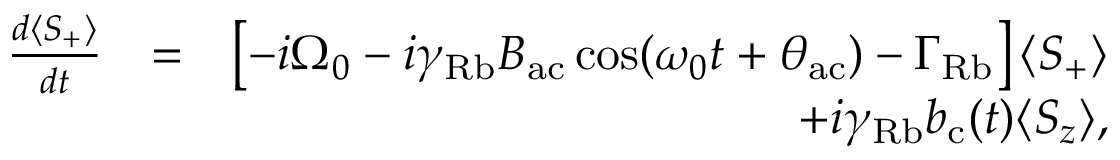<formula> <loc_0><loc_0><loc_500><loc_500>\begin{array} { r l r } { \frac { d \langle S _ { + } \rangle } { d t } } & { = } & { \left [ - i \Omega _ { 0 } - i \gamma _ { R b } B _ { a c } \cos ( \omega _ { 0 } t + \theta _ { a c } ) - \Gamma _ { R b } \right ] \langle S _ { + } \rangle } \\ & { + i \gamma _ { R b } b _ { c } ( t ) \langle S _ { z } \rangle , } \end{array}</formula> 